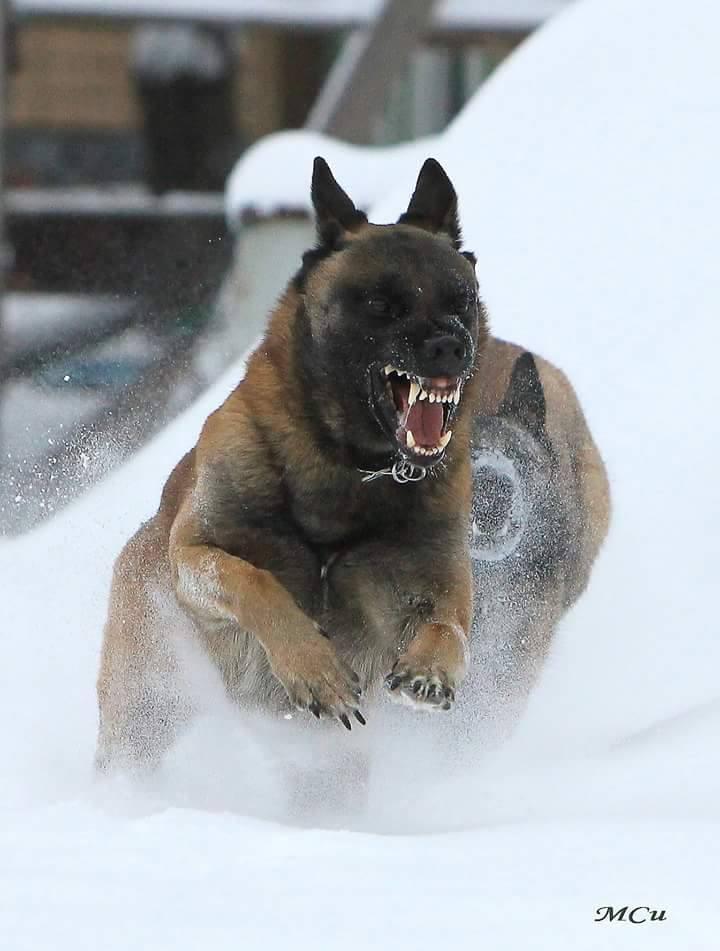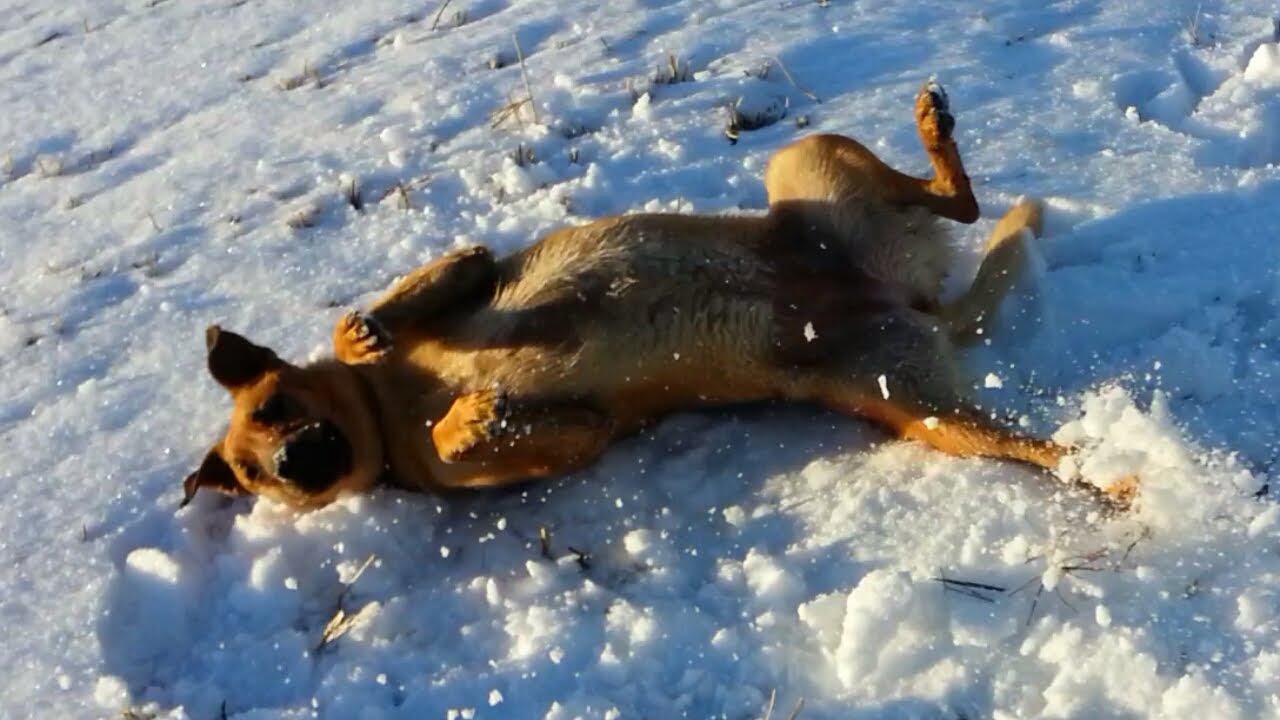The first image is the image on the left, the second image is the image on the right. Given the left and right images, does the statement "The dog in the image on the left is baring its teeth." hold true? Answer yes or no. Yes. The first image is the image on the left, the second image is the image on the right. For the images displayed, is the sentence "An image shows one german shepherd dog with a dusting of snow on the fur of its face." factually correct? Answer yes or no. No. 